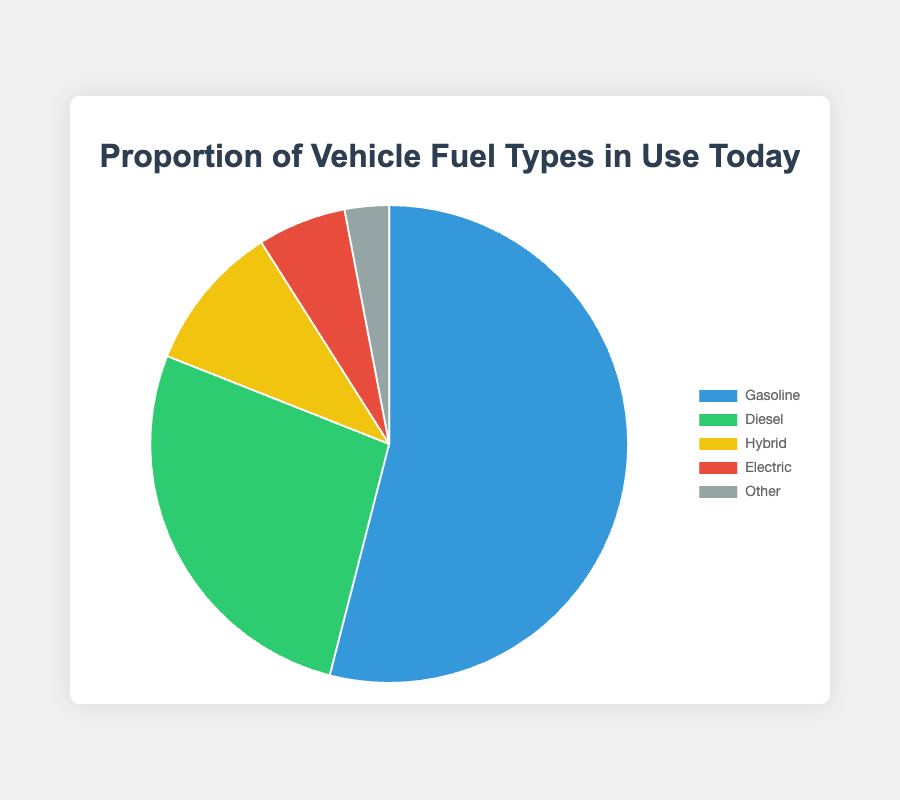What is the most common vehicle fuel type in use today? The most common fuel type can be identified as the segment of the pie chart occupying the largest area. The largest segment represents Gasoline.
Answer: Gasoline How much more prevalent is Gasoline compared to Electric? To find this, subtract the percentage for Electric from the percentage for Gasoline. Gasoline is 54%, and Electric is 6%. The difference is 54% - 6% = 48%.
Answer: 48% Which fuel type is represented by the smallest segment of the pie chart? The smallest segment of the pie chart visually represents the smallest percentage, which corresponds to Other at 3%.
Answer: Other Sum the percentages of Hybrid and Electric fuel types. Add the percentage values for Hybrid and Electric. Hybrid is 10%, and Electric is 6%. The sum is 10% + 6% = 16%.
Answer: 16% Which two fuel types combined account for more than half of the pie chart? Identify two fuel types whose combined percentages exceed 50%. Gasoline (54%) and Diesel (27%) combined equal 54% + 27% = 81%, which is more than half.
Answer: Gasoline and Diesel Among Diesel, Hybrid, and Electric, which one is least prevalent? Compare the percentages: Diesel is 27%, Hybrid is 10%, and Electric is 6%. The smallest percentage is Electric.
Answer: Electric What is the combined percentage of all non-Gasoline vehicles? Sum the percentages of Diesel, Hybrid, Electric, and Other: 27% + 10% + 6% + 3% = 46%.
Answer: 46% Is the percentage of Diesel vehicles greater than that of all non-Hybrid vehicles combined? Compare Diesel's percentage (27%) to the sum of percentages of Gasoline, Diesel, Electric, and Other: 54% + 27% + 6% + 3% = 90%. Diesel (27%) is not greater than this combined sum (90%).
Answer: No What proportion of the chart is taken up by vehicles using alternative fuels (Hybrid, Electric, Other)? Add the percentages for Hybrid, Electric, and Other: 10% + 6% + 3% = 19%.
Answer: 19% Which fuel type is represented by the green color? By visually inspecting the pie chart, the green segment corresponds to Diesel at 27%.
Answer: Diesel 